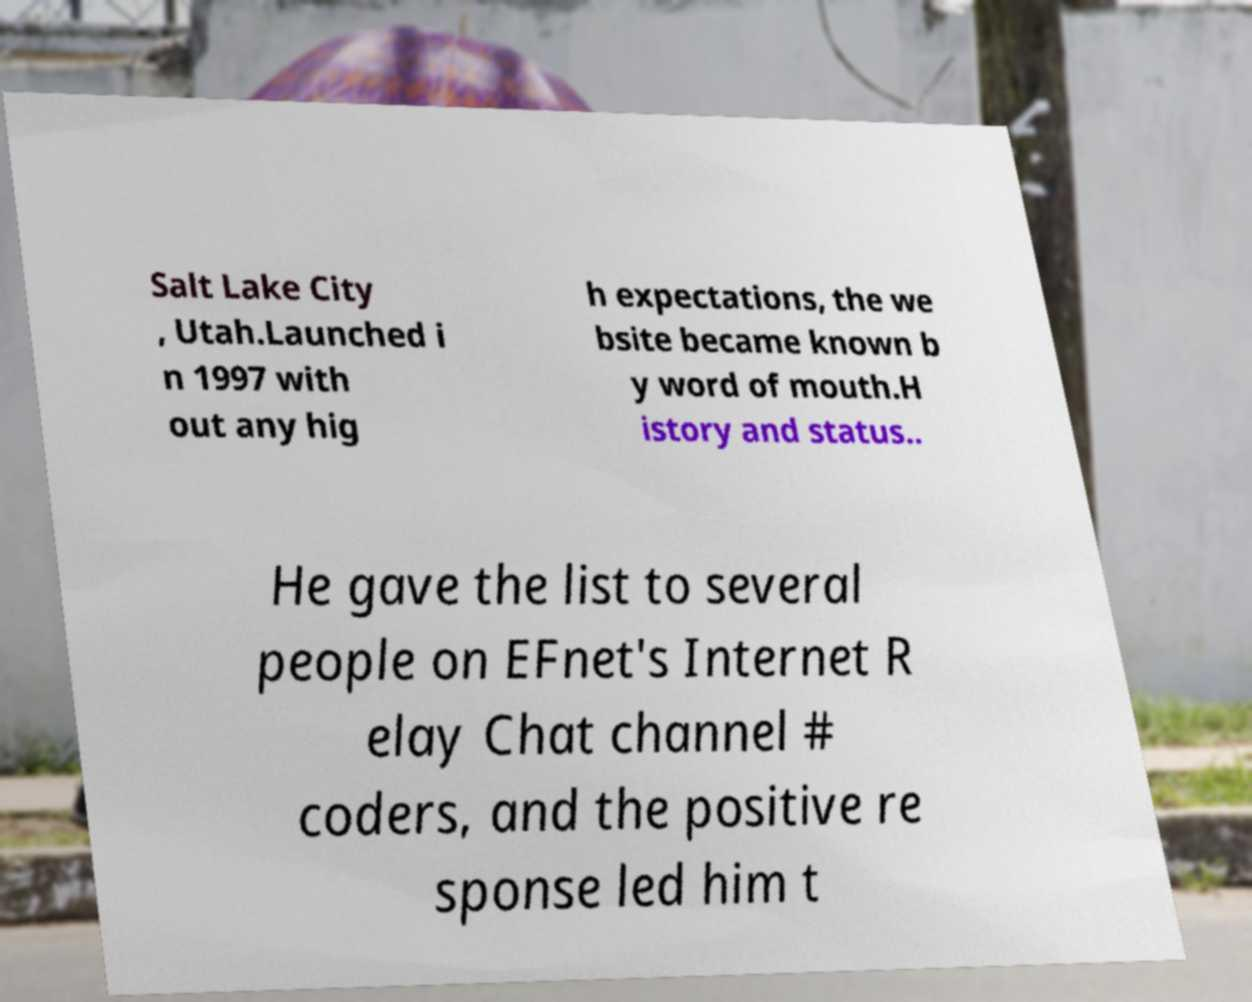Please identify and transcribe the text found in this image. Salt Lake City , Utah.Launched i n 1997 with out any hig h expectations, the we bsite became known b y word of mouth.H istory and status.. He gave the list to several people on EFnet's Internet R elay Chat channel # coders, and the positive re sponse led him t 